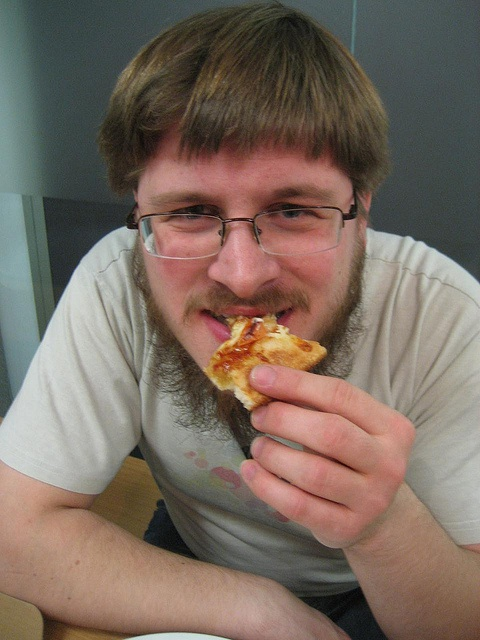Describe the objects in this image and their specific colors. I can see people in teal, gray, darkgray, and black tones, pizza in teal, red, tan, and salmon tones, and dining table in teal, olive, gray, and black tones in this image. 